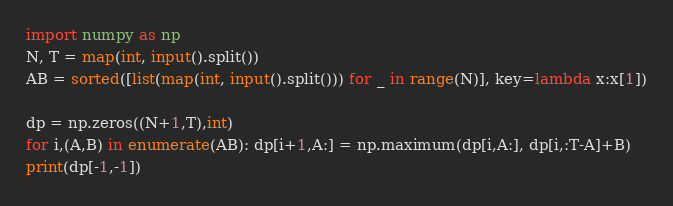Convert code to text. <code><loc_0><loc_0><loc_500><loc_500><_Python_>import numpy as np
N, T = map(int, input().split())
AB = sorted([list(map(int, input().split())) for _ in range(N)], key=lambda x:x[1])

dp = np.zeros((N+1,T),int)
for i,(A,B) in enumerate(AB): dp[i+1,A:] = np.maximum(dp[i,A:], dp[i,:T-A]+B)
print(dp[-1,-1])</code> 